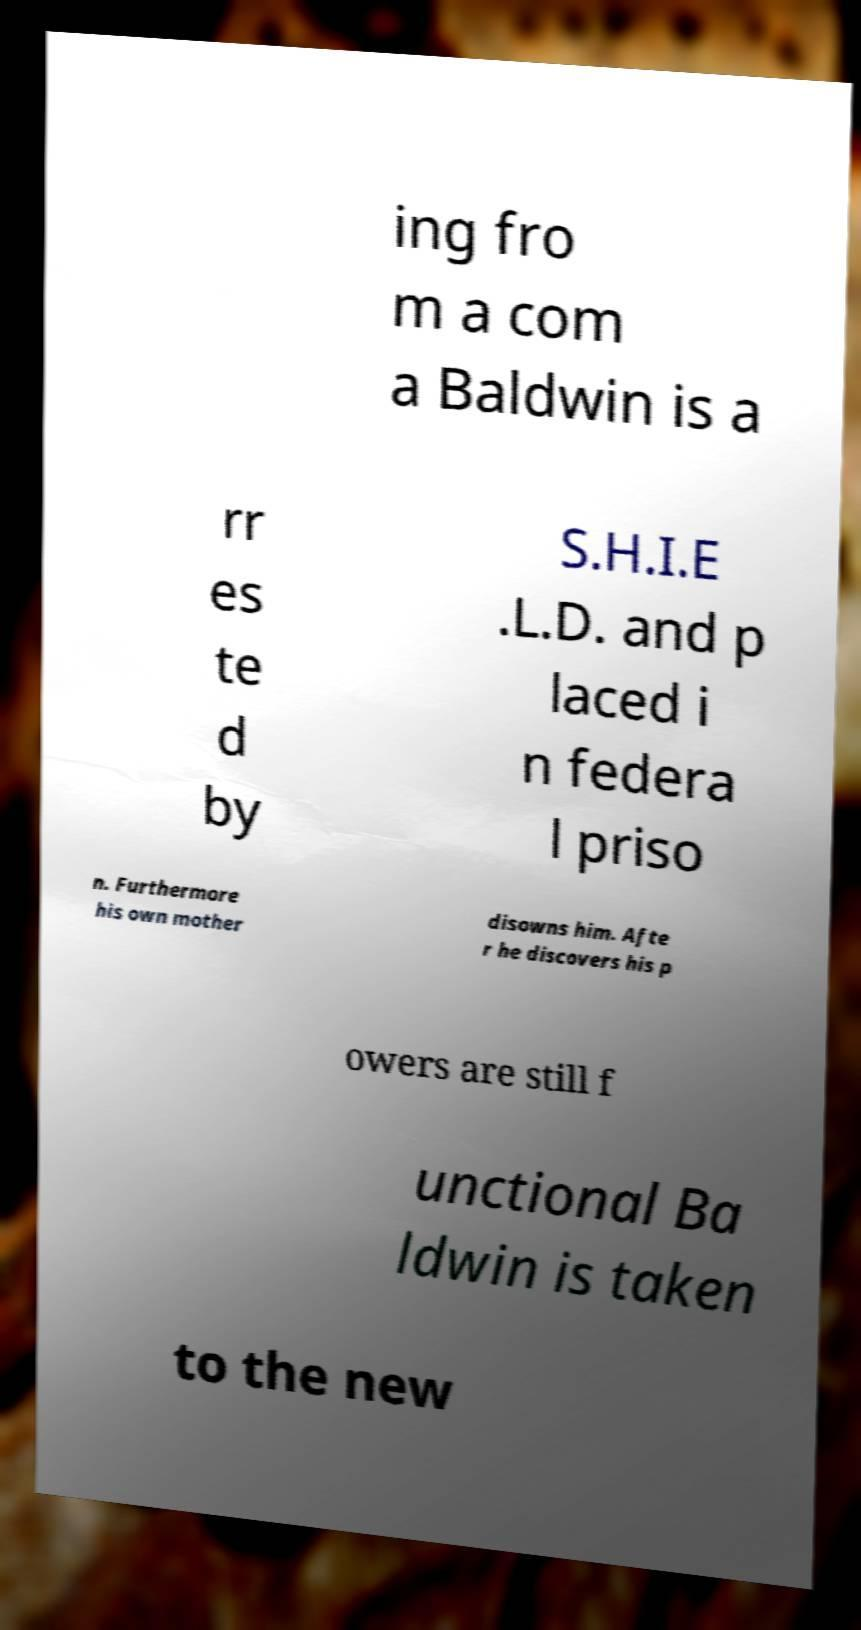Can you accurately transcribe the text from the provided image for me? ing fro m a com a Baldwin is a rr es te d by S.H.I.E .L.D. and p laced i n federa l priso n. Furthermore his own mother disowns him. Afte r he discovers his p owers are still f unctional Ba ldwin is taken to the new 